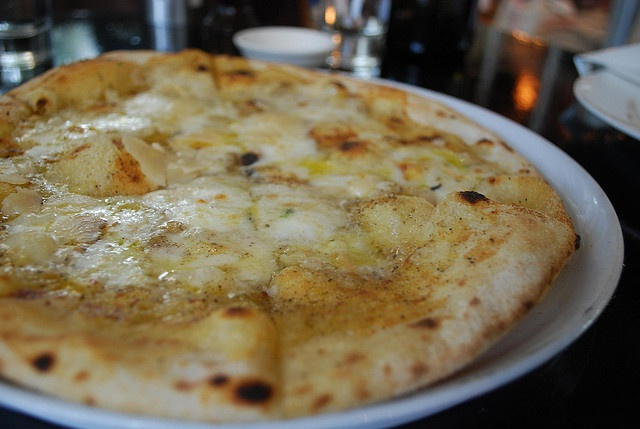Describe the objects in this image and their specific colors. I can see pizza in black, tan, olive, and darkgray tones, dining table in black, gray, and maroon tones, cup in black, gray, and darkgray tones, bowl in black, darkgray, gray, and lightgray tones, and cup in black, darkgray, purple, gray, and lightblue tones in this image. 